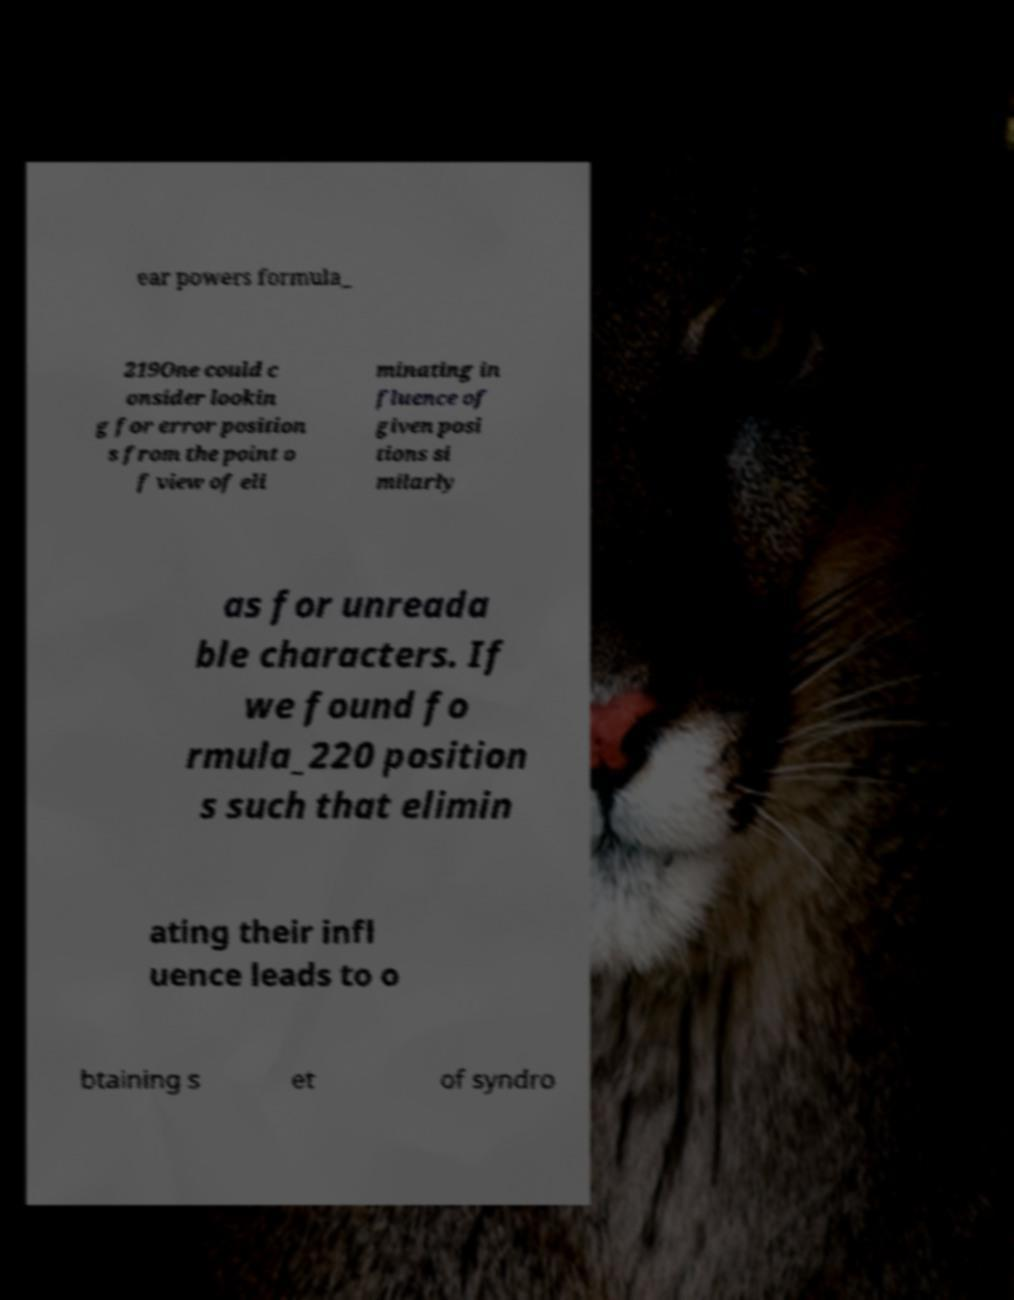What messages or text are displayed in this image? I need them in a readable, typed format. ear powers formula_ 219One could c onsider lookin g for error position s from the point o f view of eli minating in fluence of given posi tions si milarly as for unreada ble characters. If we found fo rmula_220 position s such that elimin ating their infl uence leads to o btaining s et of syndro 